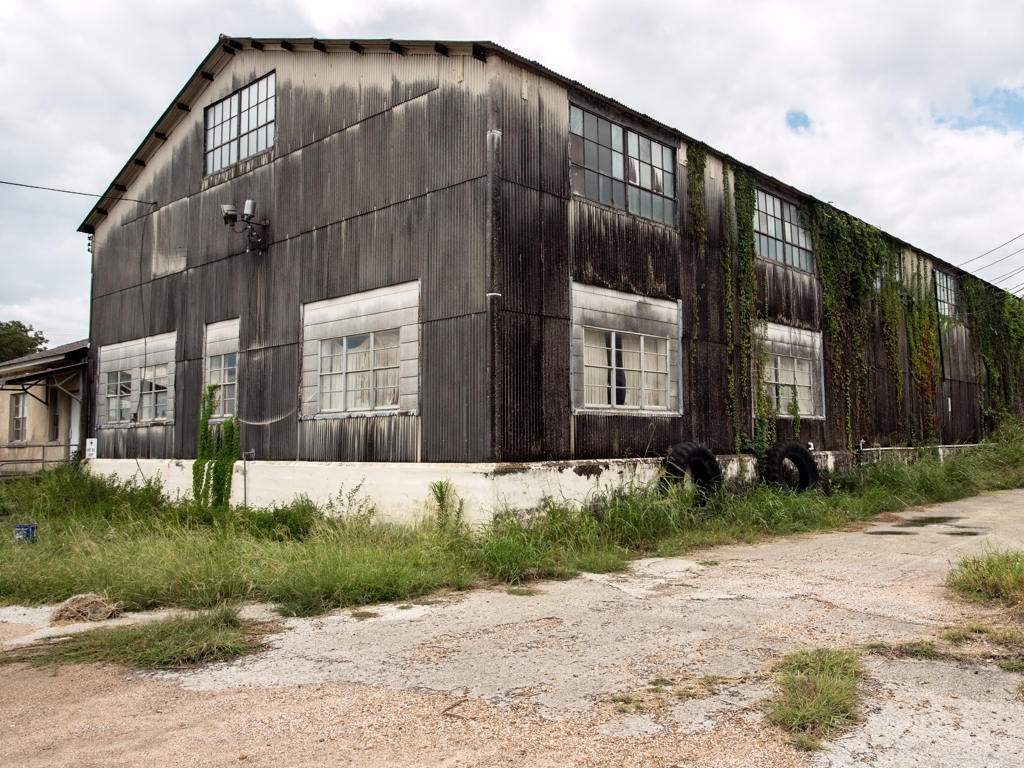Can you describe the architectural style or era this building might belong to? The building in the image features industrial architectural elements common in the early to mid-20th century. This includes the corrugated metal siding, large industrial windows, and the overall utilitarian design. The modest detailing and emphasis on function suggest it may have been used for manufacturing or storage during that period. 